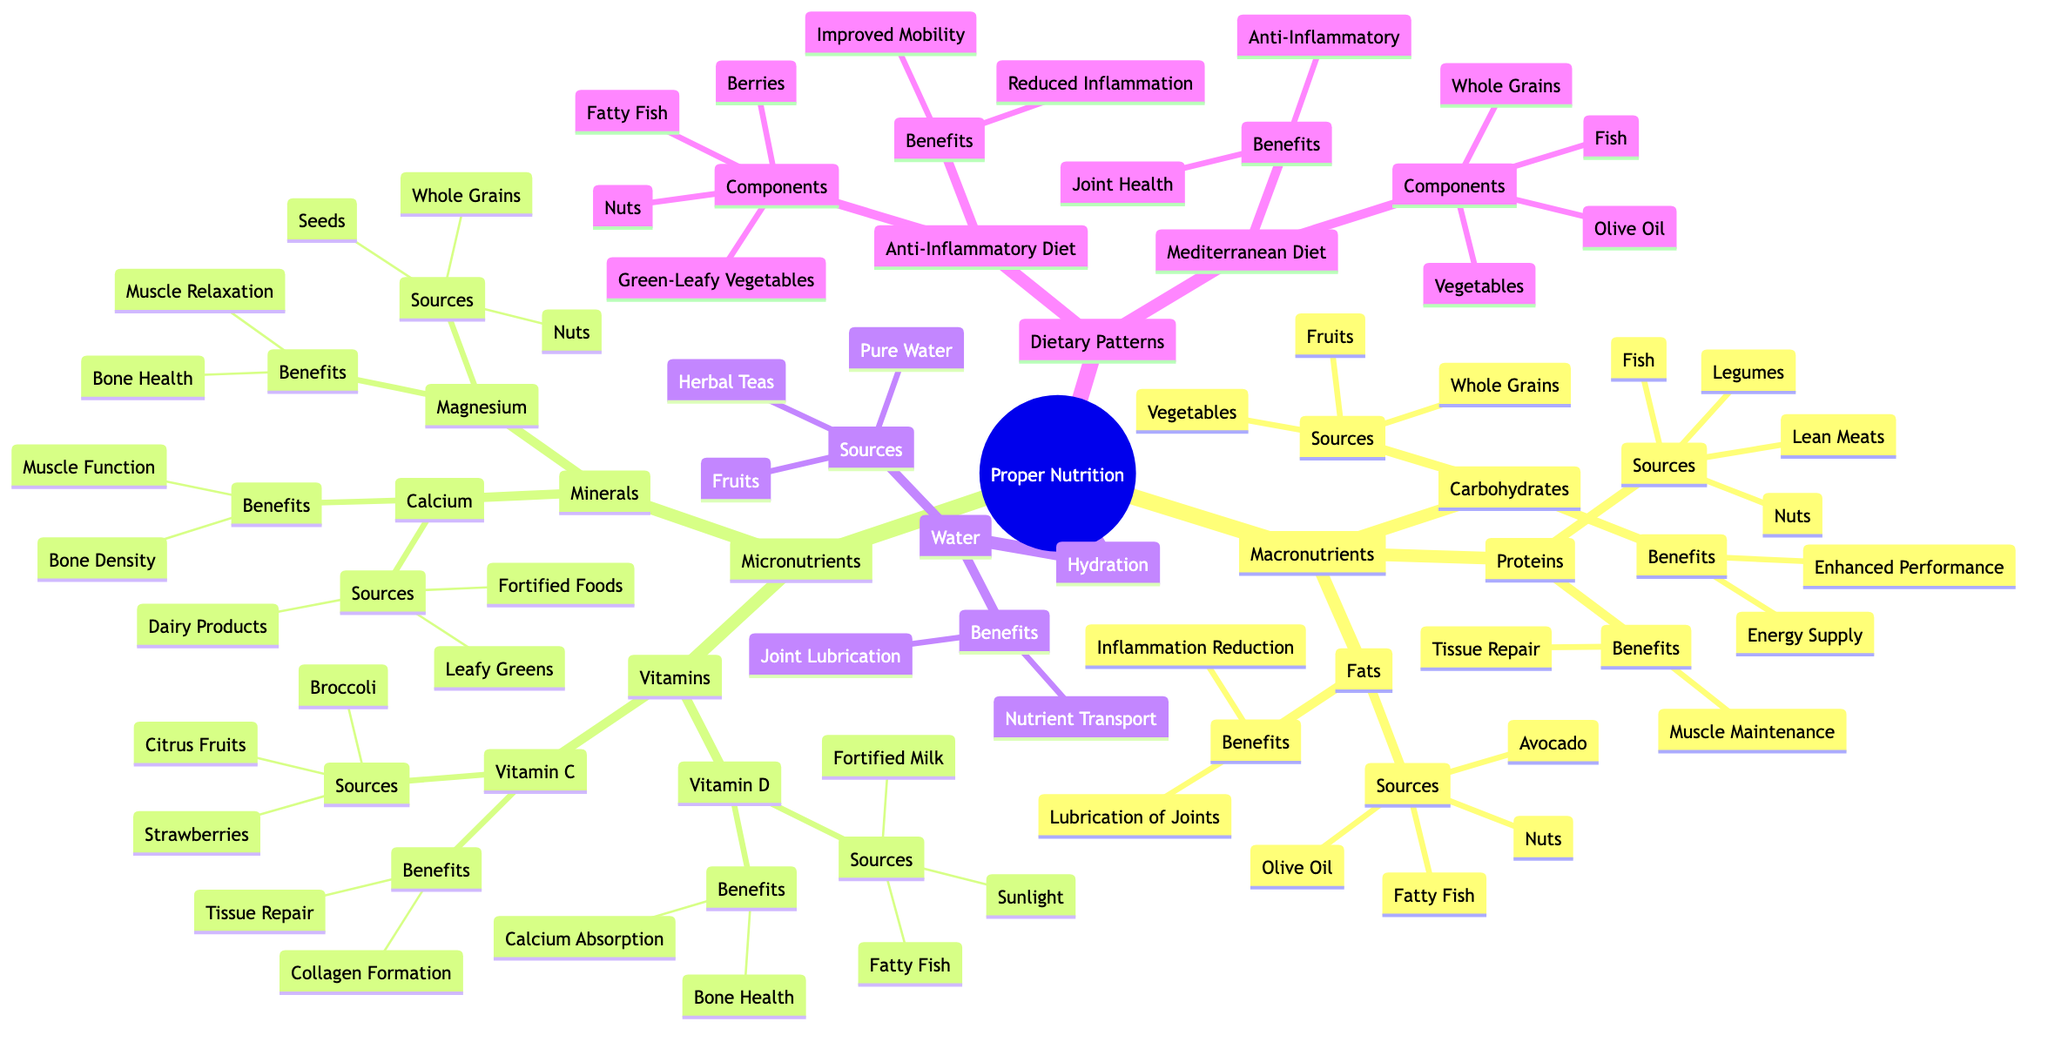What are the sources of proteins? The diagram shows the "Sources" under "Proteins," which include "Lean Meats," "Fish," "Legumes," and "Nuts."
Answer: Lean Meats, Fish, Legumes, Nuts What are the benefits of magnesium? Under "Minerals" in the diagram, the benefits of "Magnesium" are listed as "Muscle Relaxation" and "Bone Health."
Answer: Muscle Relaxation, Bone Health How many types of macronutrients are there? The diagram indicates three categories under "Macronutrients": "Proteins," "Fats," and "Carbohydrates." Counting these categories gives us three.
Answer: 3 What components are included in the Mediterranean diet? The diagram lists "Olive Oil," "Fish," "Vegetables," and "Whole Grains" as the "Components" of the "Mediterranean Diet."
Answer: Olive Oil, Fish, Vegetables, Whole Grains What is the main benefit of the anti-inflammatory diet? The diagram states that the "Benefits" of the "Anti-Inflammatory Diet" include "Reduced Inflammation" and "Improved Mobility." Focusing on the first benefit gives us the answer.
Answer: Reduced Inflammation Which vitamin helps with collagen formation? According to the diagram, "Vitamin C" is listed under "Vitamins" with the benefit of "Collagen Formation."
Answer: Vitamin C How does hydration affect joint health? The diagram indicates that "Water" contributes to "Joint Lubrication" and "Nutrient Transport," both crucial for joint health.
Answer: Joint Lubrication, Nutrient Transport What are the sources of Vitamin D? The diagram lists "Sunlight," "Fortified Milk," and "Fatty Fish" as the sources of "Vitamin D" under "Vitamins."
Answer: Sunlight, Fortified Milk, Fatty Fish 